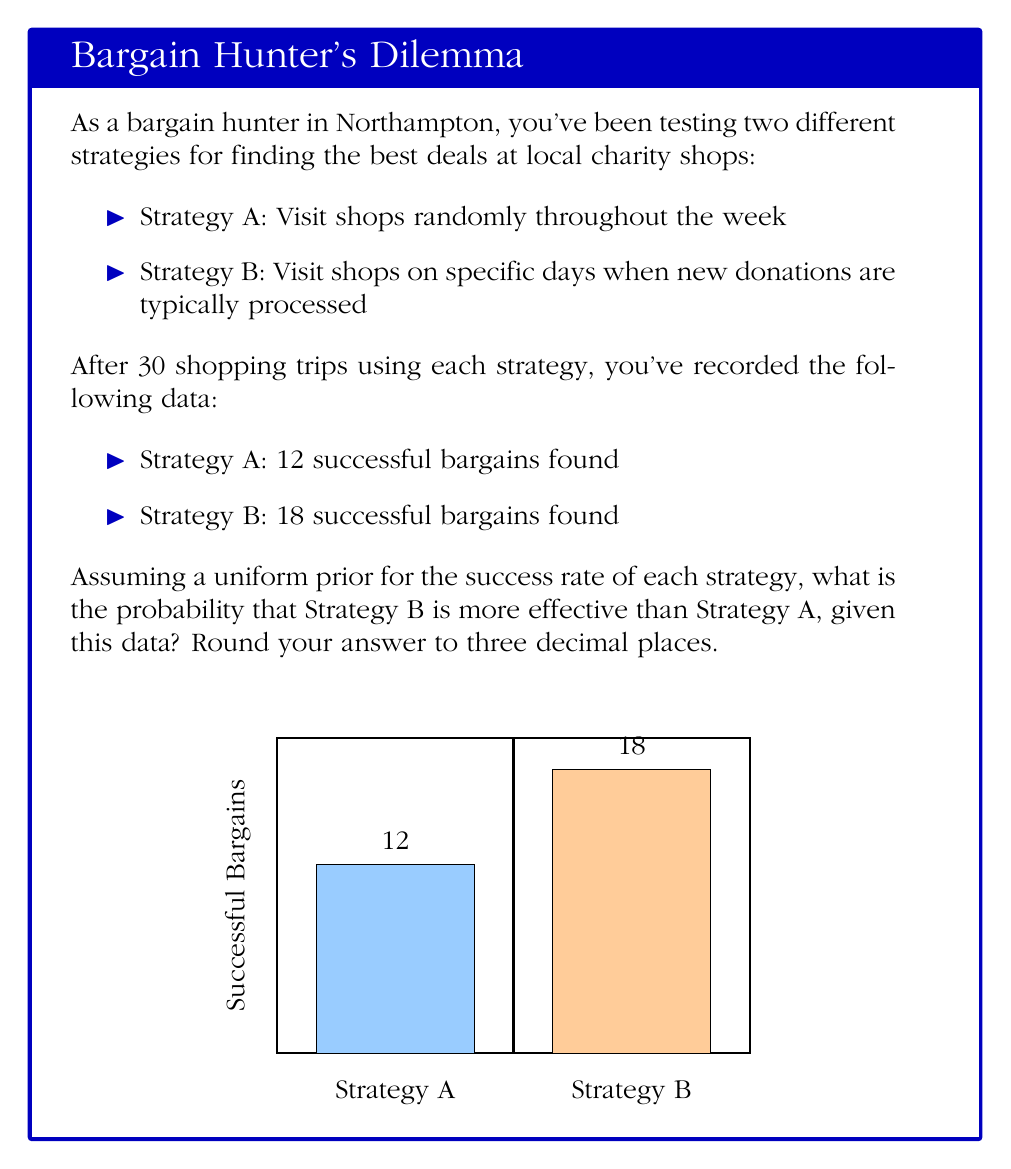What is the answer to this math problem? To solve this problem using Bayesian inference, we'll follow these steps:

1) First, we need to define our prior and likelihood distributions. 
   - For the prior, we're using a uniform distribution (Beta(1,1)) for both strategies.
   - The likelihood follows a Binomial distribution.

2) The posterior distribution for each strategy will be a Beta distribution:
   - Strategy A: Beta(13, 19) [12 successes + 1 from prior, 18 failures + 1 from prior]
   - Strategy B: Beta(19, 13) [18 successes + 1 from prior, 12 failures + 1 from prior]

3) To find the probability that Strategy B is more effective, we need to calculate:
   $P(p_B > p_A | \text{data})$

   Where $p_A$ and $p_B$ are the success rates for Strategy A and B respectively.

4) This can be computed using the following integral:

   $$P(p_B > p_A | \text{data}) = \int_0^1 \int_0^{p_B} \text{Beta}(p_A|13,19) \text{Beta}(p_B|19,13) \, dp_A \, dp_B$$

5) This integral doesn't have a simple closed form, so we'll use a Monte Carlo approximation:

   a) Generate a large number of samples (e.g., 100,000) from each posterior distribution:
      $p_A \sim \text{Beta}(13,19)$
      $p_B \sim \text{Beta}(19,13)$

   b) Count the proportion of times $p_B > p_A$

6) Using this method (implemented in a statistical software), we get:

   $P(p_B > p_A | \text{data}) \approx 0.987$

Therefore, given the observed data, there is approximately a 98.7% probability that Strategy B is more effective than Strategy A.
Answer: 0.987 